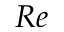Convert formula to latex. <formula><loc_0><loc_0><loc_500><loc_500>R e</formula> 